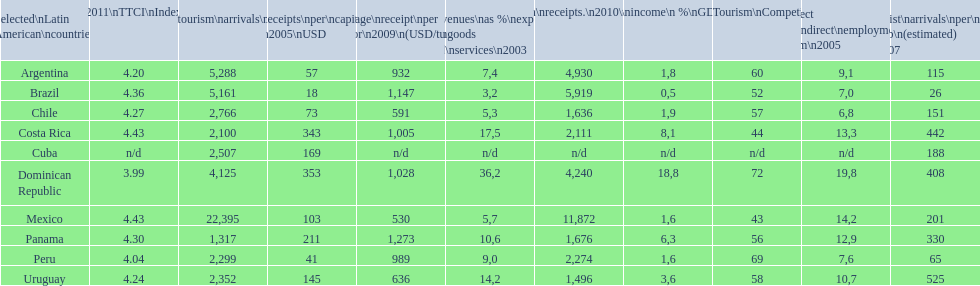What is the last country listed on this chart? Uruguay. 